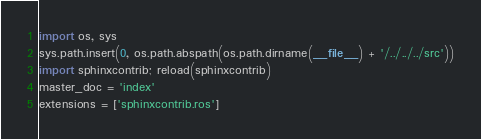<code> <loc_0><loc_0><loc_500><loc_500><_Python_>import os, sys
sys.path.insert(0, os.path.abspath(os.path.dirname(__file__) + '/../../../src'))
import sphinxcontrib; reload(sphinxcontrib)
master_doc = 'index'
extensions = ['sphinxcontrib.ros']
</code> 